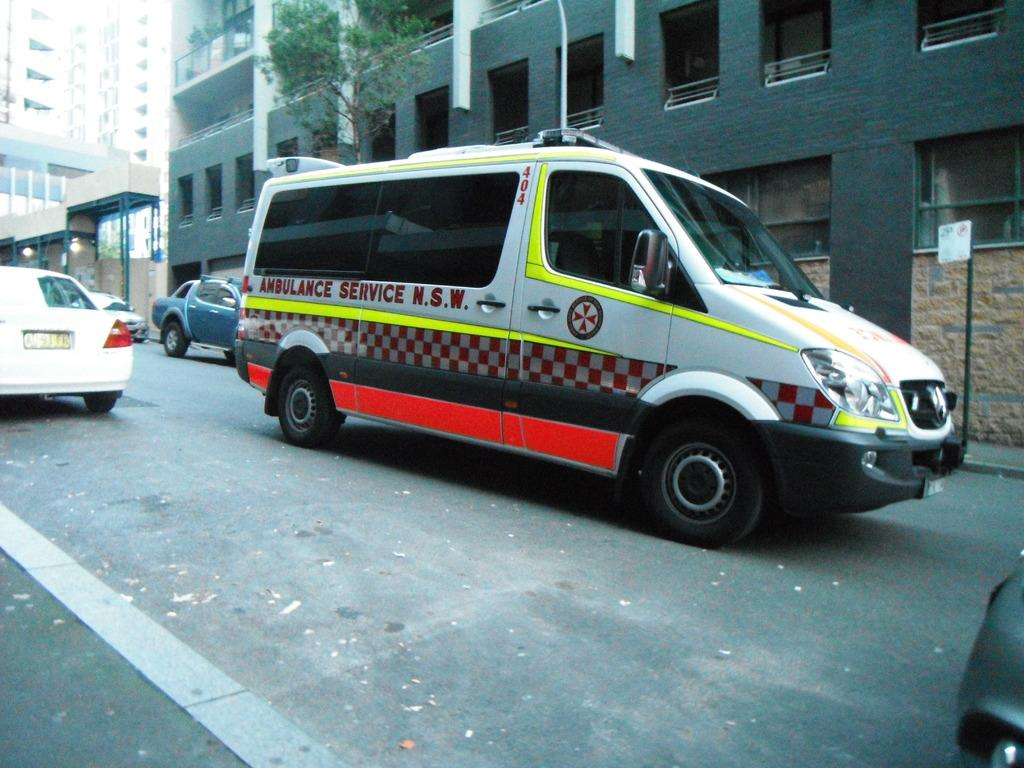<image>
Describe the image concisely. A van from the N.S.W. Ambulance Service drives down the street. 